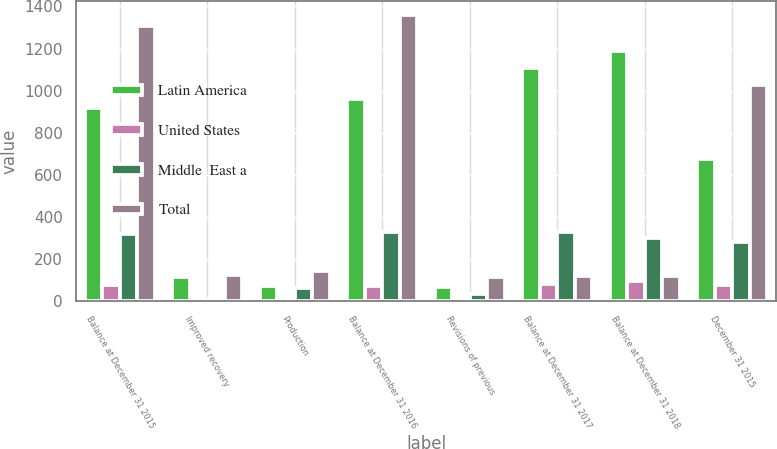<chart> <loc_0><loc_0><loc_500><loc_500><stacked_bar_chart><ecel><fcel>Balance at December 31 2015<fcel>Improved recovery<fcel>Production<fcel>Balance at December 31 2016<fcel>Revisions of previous<fcel>Balance at December 31 2017<fcel>Balance at December 31 2018<fcel>December 31 2015<nl><fcel>Latin America<fcel>915<fcel>114<fcel>69<fcel>960<fcel>66<fcel>1107<fcel>1186<fcel>673<nl><fcel>United States<fcel>77<fcel>2<fcel>12<fcel>71<fcel>14<fcel>82<fcel>96<fcel>77<nl><fcel>Middle  East a<fcel>317<fcel>9<fcel>62<fcel>326<fcel>33<fcel>326<fcel>301<fcel>278<nl><fcel>Total<fcel>1309<fcel>125<fcel>143<fcel>1357<fcel>113<fcel>119.5<fcel>119.5<fcel>1028<nl></chart> 